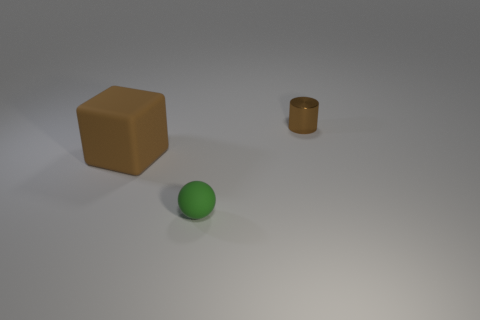Add 2 tiny brown shiny cylinders. How many objects exist? 5 Subtract all cubes. How many objects are left? 2 Subtract 0 gray cubes. How many objects are left? 3 Subtract all big rubber objects. Subtract all tiny red shiny things. How many objects are left? 2 Add 1 tiny green rubber things. How many tiny green rubber things are left? 2 Add 2 tiny rubber cylinders. How many tiny rubber cylinders exist? 2 